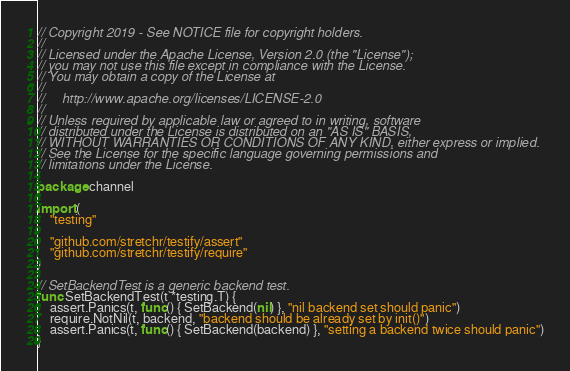<code> <loc_0><loc_0><loc_500><loc_500><_Go_>// Copyright 2019 - See NOTICE file for copyright holders.
//
// Licensed under the Apache License, Version 2.0 (the "License");
// you may not use this file except in compliance with the License.
// You may obtain a copy of the License at
//
//     http://www.apache.org/licenses/LICENSE-2.0
//
// Unless required by applicable law or agreed to in writing, software
// distributed under the License is distributed on an "AS IS" BASIS,
// WITHOUT WARRANTIES OR CONDITIONS OF ANY KIND, either express or implied.
// See the License for the specific language governing permissions and
// limitations under the License.

package channel

import (
	"testing"

	"github.com/stretchr/testify/assert"
	"github.com/stretchr/testify/require"
)

// SetBackendTest is a generic backend test.
func SetBackendTest(t *testing.T) {
	assert.Panics(t, func() { SetBackend(nil) }, "nil backend set should panic")
	require.NotNil(t, backend, "backend should be already set by init()")
	assert.Panics(t, func() { SetBackend(backend) }, "setting a backend twice should panic")
}
</code> 